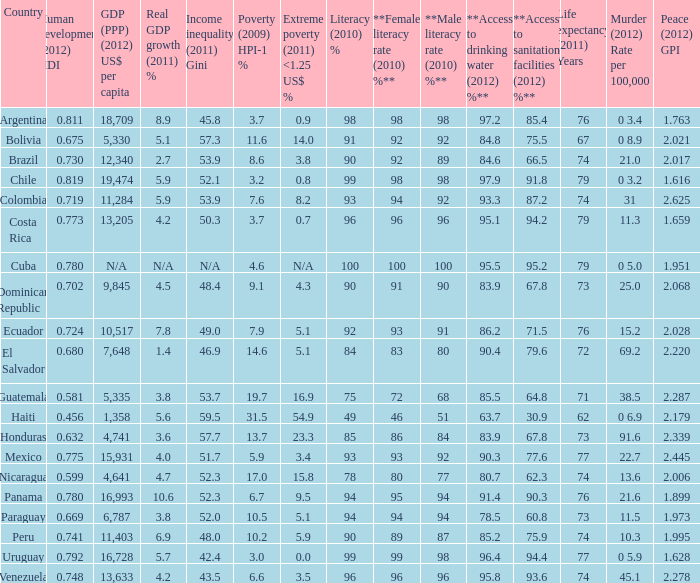What is the sum of poverty (2009) HPI-1 % when the GDP (PPP) (2012) US$ per capita of 11,284? 1.0. 